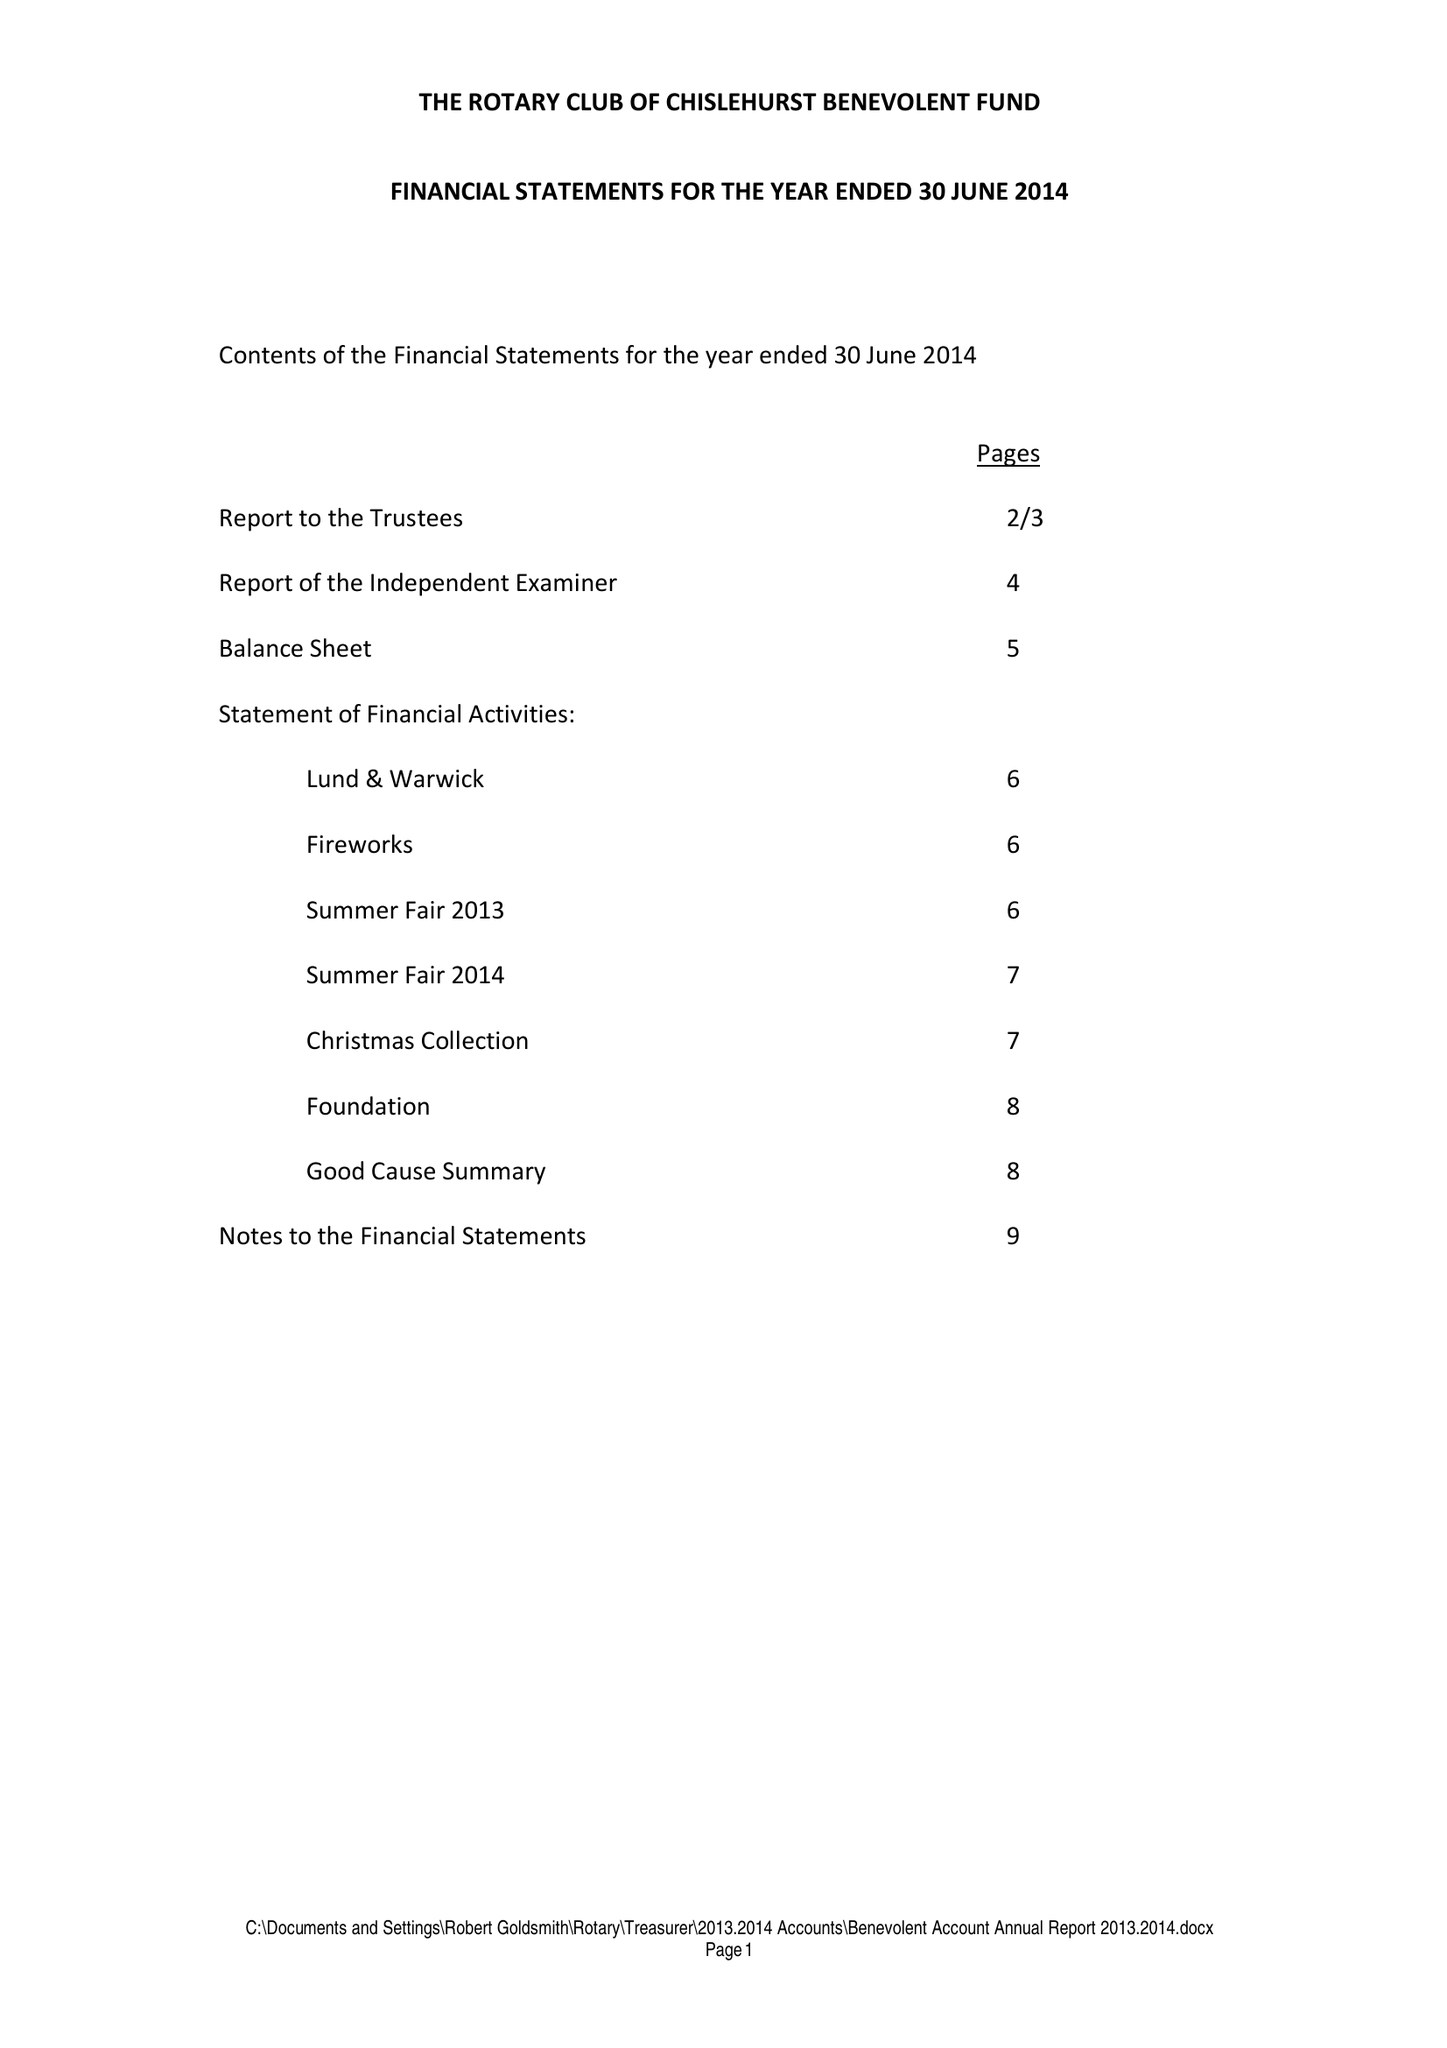What is the value for the report_date?
Answer the question using a single word or phrase. 2014-06-30 